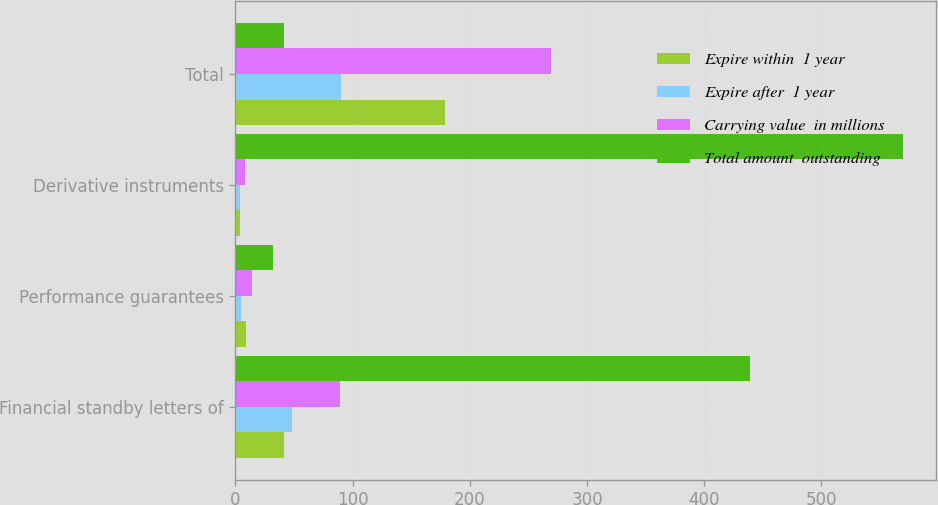Convert chart. <chart><loc_0><loc_0><loc_500><loc_500><stacked_bar_chart><ecel><fcel>Financial standby letters of<fcel>Performance guarantees<fcel>Derivative instruments<fcel>Total<nl><fcel>Expire within  1 year<fcel>41.4<fcel>9.4<fcel>4.1<fcel>179.1<nl><fcel>Expire after  1 year<fcel>48<fcel>4.5<fcel>3.6<fcel>89.9<nl><fcel>Carrying value  in millions<fcel>89.4<fcel>13.9<fcel>7.7<fcel>269<nl><fcel>Total amount  outstanding<fcel>438.8<fcel>32.4<fcel>569.2<fcel>41.4<nl></chart> 